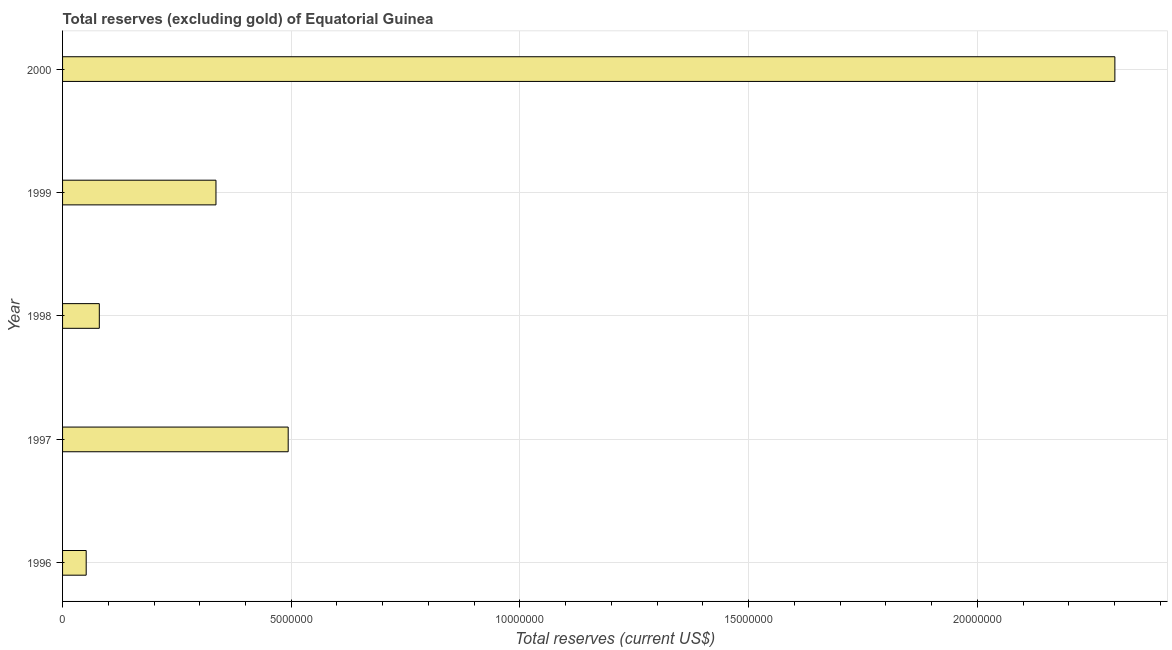What is the title of the graph?
Provide a succinct answer. Total reserves (excluding gold) of Equatorial Guinea. What is the label or title of the X-axis?
Your answer should be compact. Total reserves (current US$). What is the total reserves (excluding gold) in 2000?
Offer a very short reply. 2.30e+07. Across all years, what is the maximum total reserves (excluding gold)?
Your answer should be very brief. 2.30e+07. Across all years, what is the minimum total reserves (excluding gold)?
Provide a short and direct response. 5.16e+05. In which year was the total reserves (excluding gold) minimum?
Ensure brevity in your answer.  1996. What is the sum of the total reserves (excluding gold)?
Your answer should be very brief. 3.26e+07. What is the difference between the total reserves (excluding gold) in 1997 and 2000?
Make the answer very short. -1.81e+07. What is the average total reserves (excluding gold) per year?
Provide a short and direct response. 6.52e+06. What is the median total reserves (excluding gold)?
Provide a short and direct response. 3.35e+06. In how many years, is the total reserves (excluding gold) greater than 23000000 US$?
Keep it short and to the point. 1. What is the ratio of the total reserves (excluding gold) in 1998 to that in 1999?
Offer a terse response. 0.24. Is the total reserves (excluding gold) in 1998 less than that in 1999?
Offer a terse response. Yes. What is the difference between the highest and the second highest total reserves (excluding gold)?
Make the answer very short. 1.81e+07. Is the sum of the total reserves (excluding gold) in 1998 and 1999 greater than the maximum total reserves (excluding gold) across all years?
Provide a succinct answer. No. What is the difference between the highest and the lowest total reserves (excluding gold)?
Keep it short and to the point. 2.25e+07. How many years are there in the graph?
Make the answer very short. 5. What is the difference between two consecutive major ticks on the X-axis?
Provide a short and direct response. 5.00e+06. Are the values on the major ticks of X-axis written in scientific E-notation?
Your answer should be compact. No. What is the Total reserves (current US$) in 1996?
Offer a very short reply. 5.16e+05. What is the Total reserves (current US$) of 1997?
Offer a very short reply. 4.93e+06. What is the Total reserves (current US$) of 1998?
Keep it short and to the point. 8.03e+05. What is the Total reserves (current US$) in 1999?
Make the answer very short. 3.35e+06. What is the Total reserves (current US$) of 2000?
Your response must be concise. 2.30e+07. What is the difference between the Total reserves (current US$) in 1996 and 1997?
Ensure brevity in your answer.  -4.42e+06. What is the difference between the Total reserves (current US$) in 1996 and 1998?
Your answer should be compact. -2.87e+05. What is the difference between the Total reserves (current US$) in 1996 and 1999?
Your answer should be very brief. -2.84e+06. What is the difference between the Total reserves (current US$) in 1996 and 2000?
Provide a short and direct response. -2.25e+07. What is the difference between the Total reserves (current US$) in 1997 and 1998?
Offer a terse response. 4.13e+06. What is the difference between the Total reserves (current US$) in 1997 and 1999?
Keep it short and to the point. 1.58e+06. What is the difference between the Total reserves (current US$) in 1997 and 2000?
Offer a very short reply. -1.81e+07. What is the difference between the Total reserves (current US$) in 1998 and 1999?
Ensure brevity in your answer.  -2.55e+06. What is the difference between the Total reserves (current US$) in 1998 and 2000?
Keep it short and to the point. -2.22e+07. What is the difference between the Total reserves (current US$) in 1999 and 2000?
Keep it short and to the point. -1.97e+07. What is the ratio of the Total reserves (current US$) in 1996 to that in 1997?
Ensure brevity in your answer.  0.1. What is the ratio of the Total reserves (current US$) in 1996 to that in 1998?
Keep it short and to the point. 0.64. What is the ratio of the Total reserves (current US$) in 1996 to that in 1999?
Keep it short and to the point. 0.15. What is the ratio of the Total reserves (current US$) in 1996 to that in 2000?
Give a very brief answer. 0.02. What is the ratio of the Total reserves (current US$) in 1997 to that in 1998?
Make the answer very short. 6.14. What is the ratio of the Total reserves (current US$) in 1997 to that in 1999?
Give a very brief answer. 1.47. What is the ratio of the Total reserves (current US$) in 1997 to that in 2000?
Provide a succinct answer. 0.21. What is the ratio of the Total reserves (current US$) in 1998 to that in 1999?
Offer a very short reply. 0.24. What is the ratio of the Total reserves (current US$) in 1998 to that in 2000?
Your response must be concise. 0.04. What is the ratio of the Total reserves (current US$) in 1999 to that in 2000?
Provide a succinct answer. 0.15. 